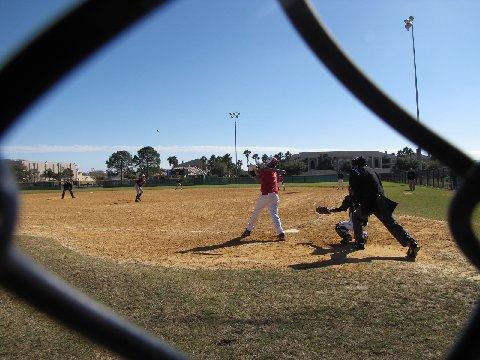How many batters do you see?
Give a very brief answer. 1. How many people can you see?
Give a very brief answer. 1. How many cars are in the picture?
Give a very brief answer. 0. 